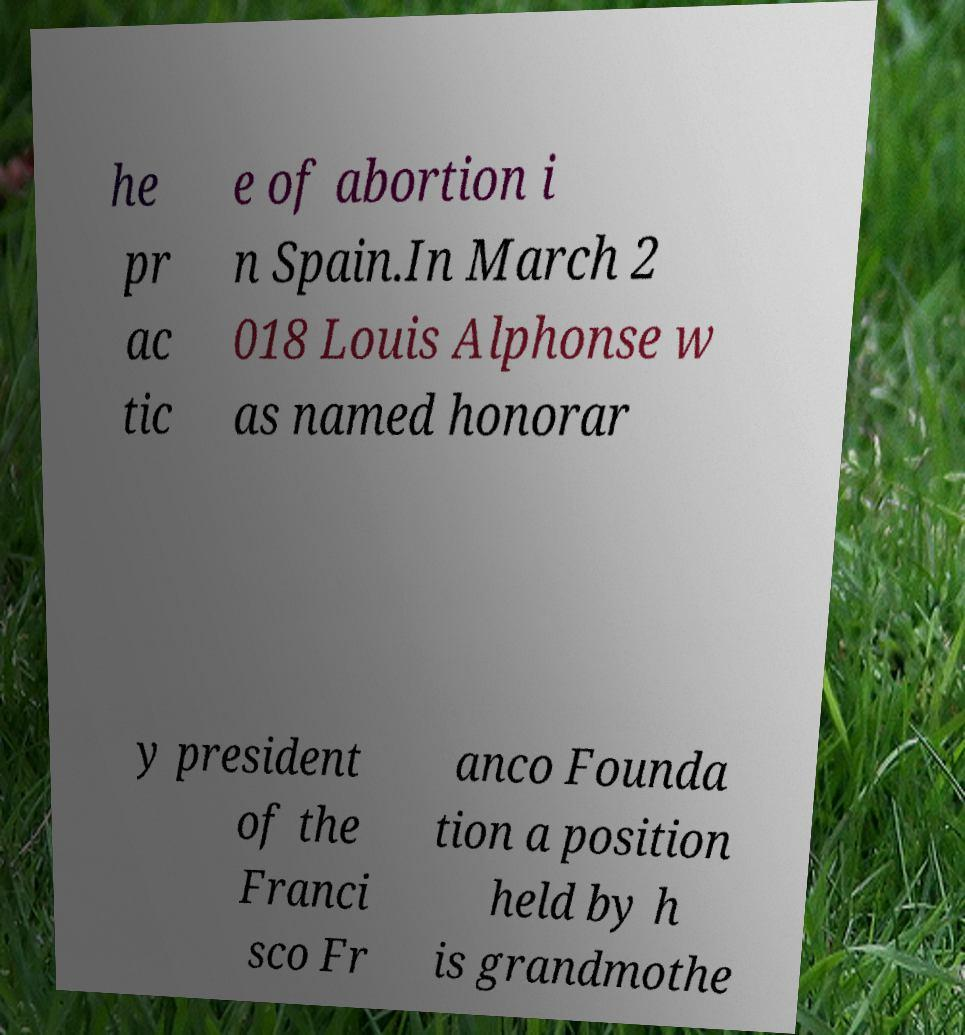Can you accurately transcribe the text from the provided image for me? he pr ac tic e of abortion i n Spain.In March 2 018 Louis Alphonse w as named honorar y president of the Franci sco Fr anco Founda tion a position held by h is grandmothe 